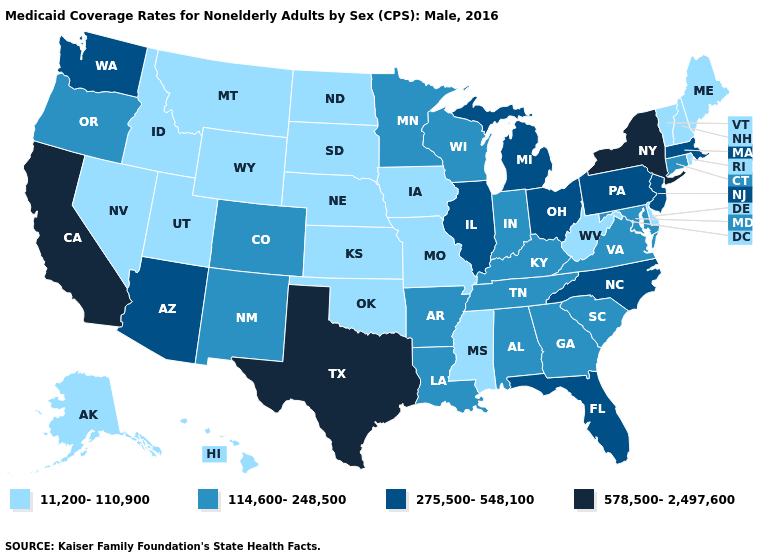What is the value of South Carolina?
Concise answer only. 114,600-248,500. How many symbols are there in the legend?
Short answer required. 4. Which states hav the highest value in the Northeast?
Keep it brief. New York. Name the states that have a value in the range 275,500-548,100?
Give a very brief answer. Arizona, Florida, Illinois, Massachusetts, Michigan, New Jersey, North Carolina, Ohio, Pennsylvania, Washington. Name the states that have a value in the range 114,600-248,500?
Quick response, please. Alabama, Arkansas, Colorado, Connecticut, Georgia, Indiana, Kentucky, Louisiana, Maryland, Minnesota, New Mexico, Oregon, South Carolina, Tennessee, Virginia, Wisconsin. What is the value of Colorado?
Keep it brief. 114,600-248,500. What is the lowest value in the USA?
Keep it brief. 11,200-110,900. What is the value of Virginia?
Quick response, please. 114,600-248,500. Among the states that border New Hampshire , does Vermont have the highest value?
Be succinct. No. What is the highest value in the South ?
Quick response, please. 578,500-2,497,600. What is the value of South Carolina?
Concise answer only. 114,600-248,500. Does the first symbol in the legend represent the smallest category?
Give a very brief answer. Yes. Does the first symbol in the legend represent the smallest category?
Be succinct. Yes. Does Missouri have the lowest value in the MidWest?
Quick response, please. Yes. What is the value of Tennessee?
Concise answer only. 114,600-248,500. 